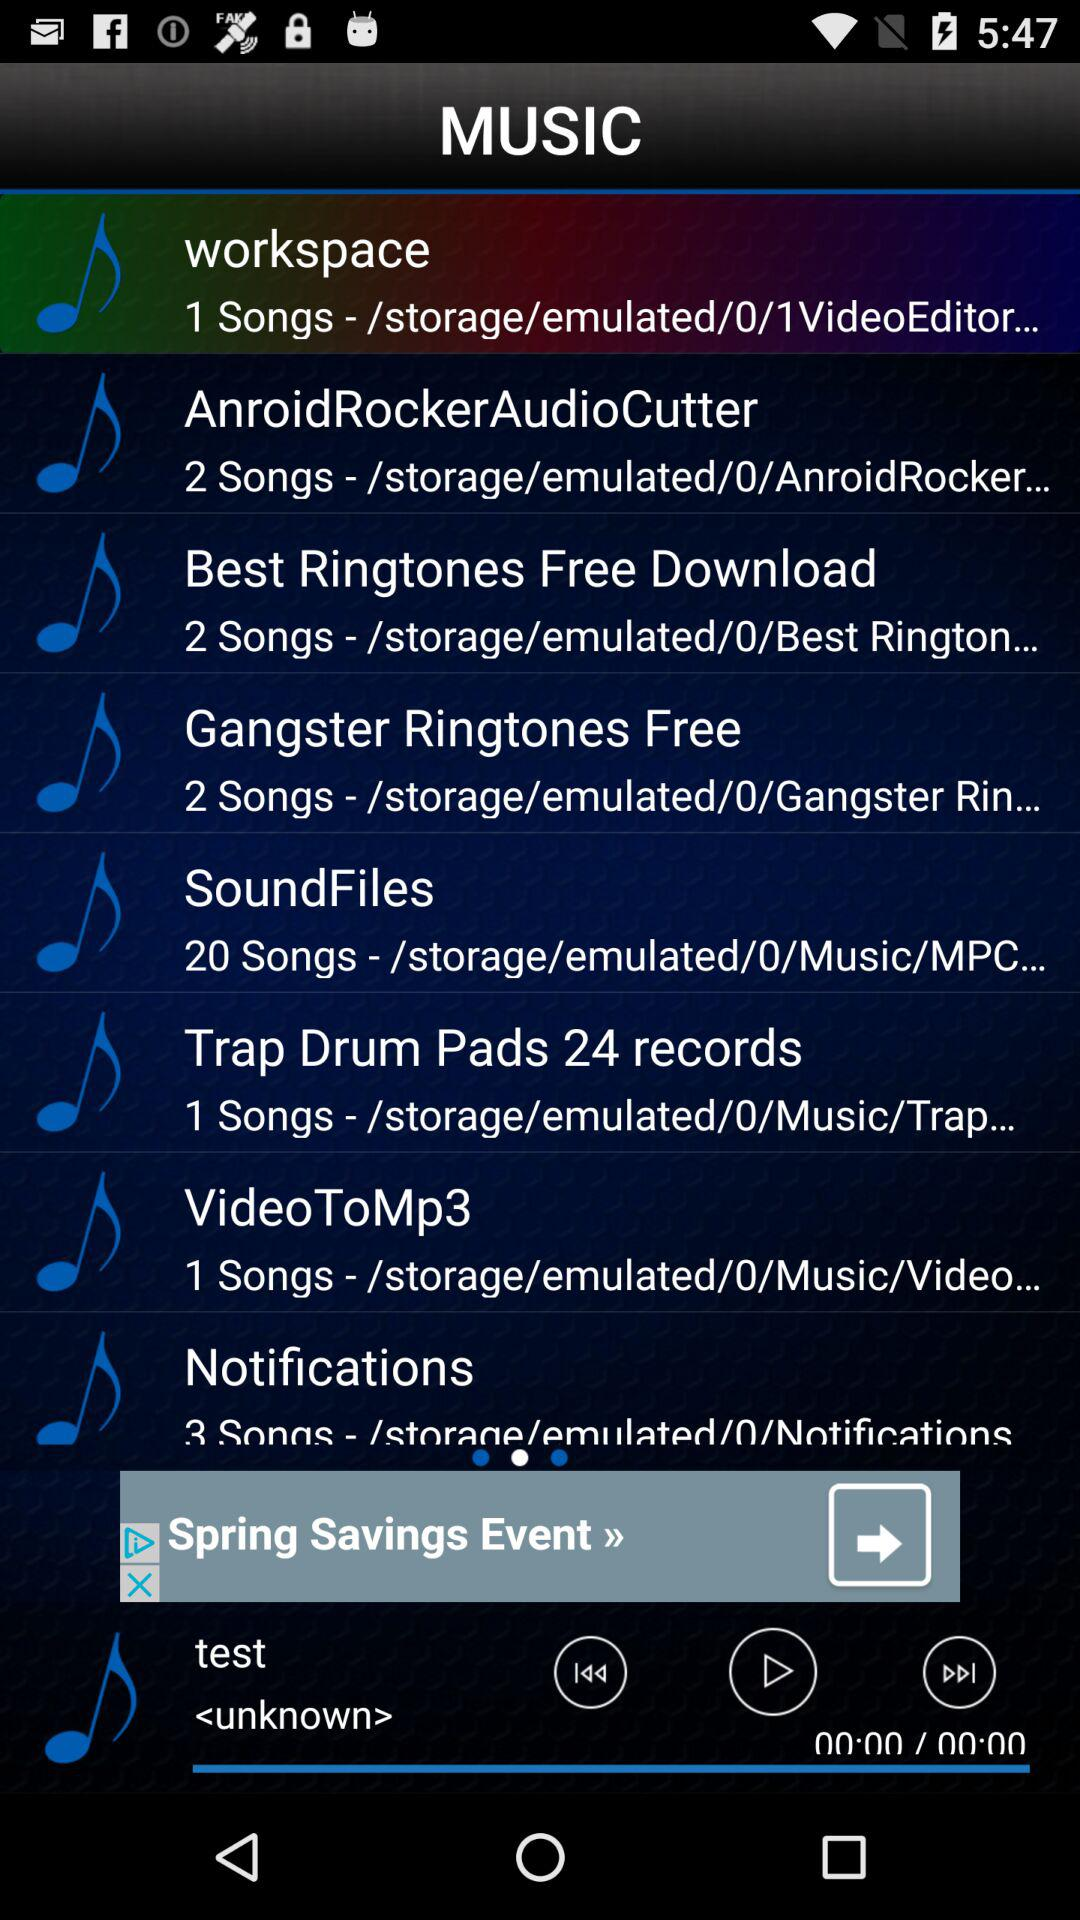How many songs are there in AndroidRockerAudioCutter? There are 2 songs in AndroidRockerAudioCutter. 